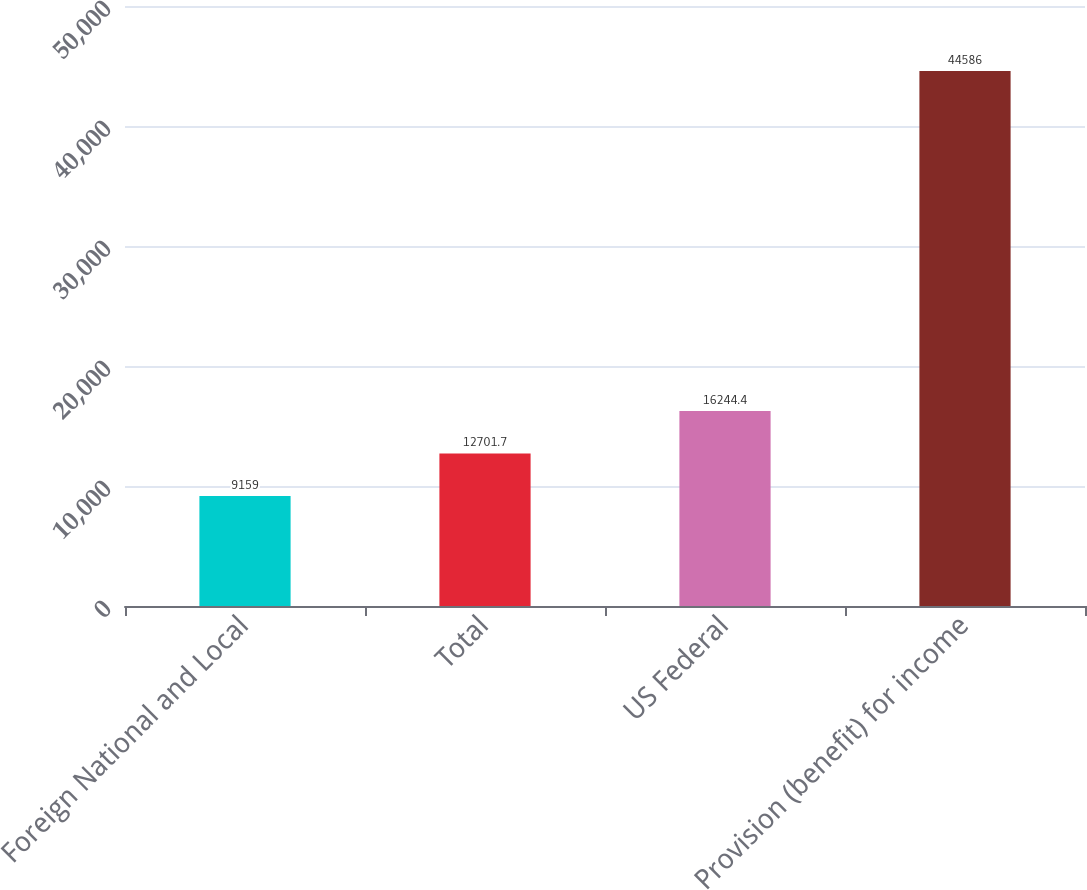Convert chart. <chart><loc_0><loc_0><loc_500><loc_500><bar_chart><fcel>Foreign National and Local<fcel>Total<fcel>US Federal<fcel>Provision (benefit) for income<nl><fcel>9159<fcel>12701.7<fcel>16244.4<fcel>44586<nl></chart> 